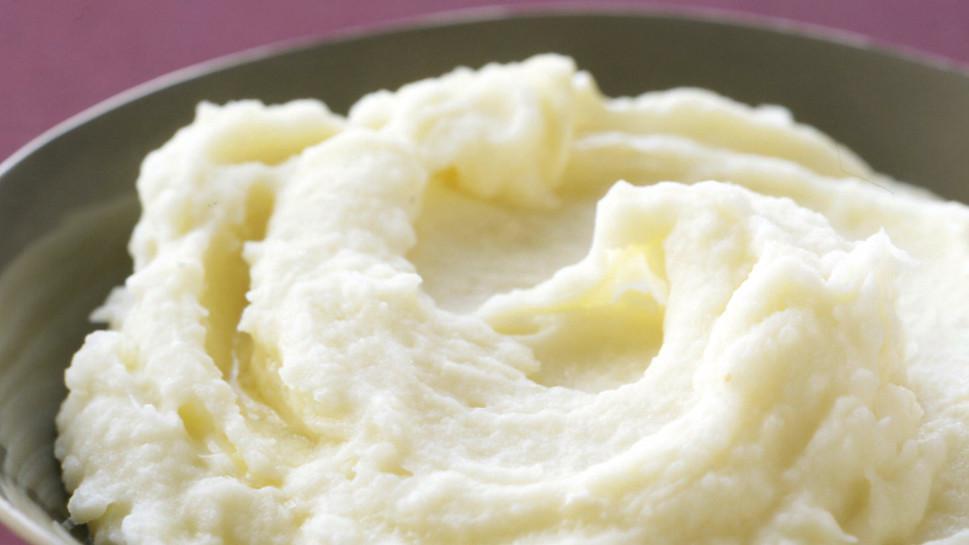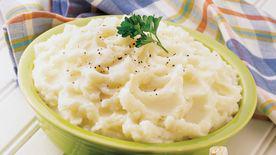The first image is the image on the left, the second image is the image on the right. Assess this claim about the two images: "The potatoes in one of the images are served a grey bowl.". Correct or not? Answer yes or no. Yes. The first image is the image on the left, the second image is the image on the right. Considering the images on both sides, is "An image shows a bowl of mashed potatoes garnished with one green sprig." valid? Answer yes or no. Yes. The first image is the image on the left, the second image is the image on the right. Given the left and right images, does the statement "At least one bowl is white." hold true? Answer yes or no. No. The first image is the image on the left, the second image is the image on the right. Assess this claim about the two images: "The dish on the right contains a large piece of green garnish.". Correct or not? Answer yes or no. Yes. The first image is the image on the left, the second image is the image on the right. Examine the images to the left and right. Is the description "The image on the right shows a mashed potato on a white bowl." accurate? Answer yes or no. No. 